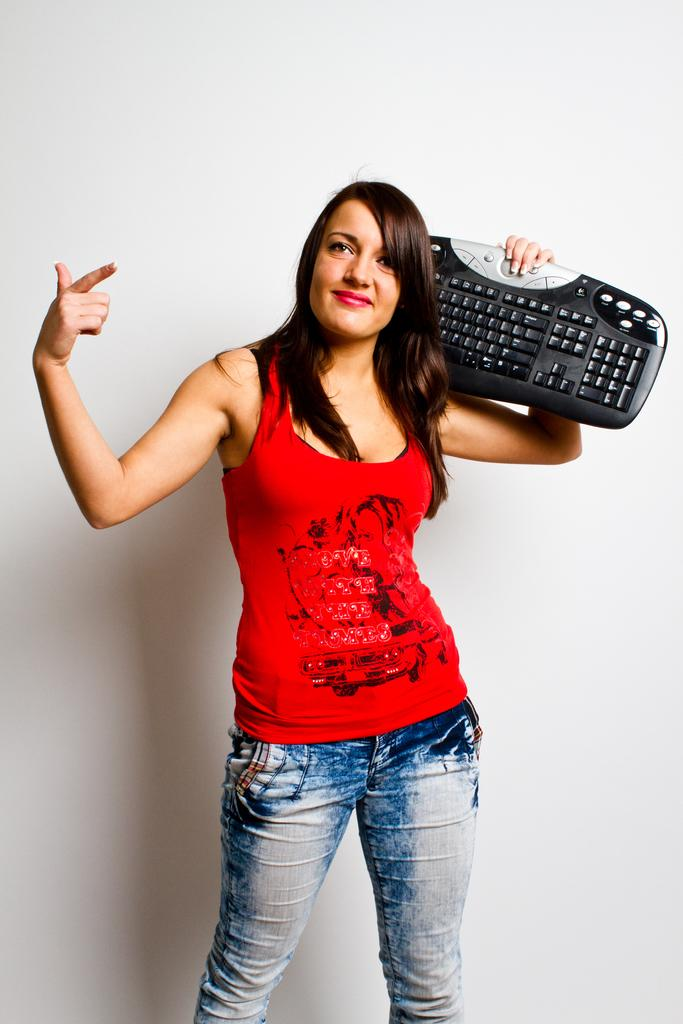Who is in the picture? There is a man in the picture. What is the man wearing? The man is wearing a t-shirt and jeans. What is the man holding in the picture? The man is holding a keyboard. What is the man's facial expression? The man is smiling. Where is the man standing in the picture? The man is standing near a wall. What type of cake is being served at the man's birthday party in the image? There is no birthday party or cake present in the image; it features a man holding a keyboard and standing near a wall. 